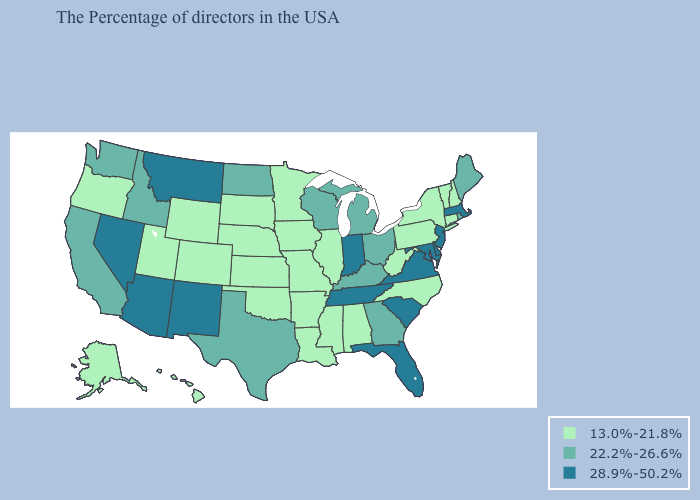Which states have the highest value in the USA?
Concise answer only. Massachusetts, New Jersey, Delaware, Maryland, Virginia, South Carolina, Florida, Indiana, Tennessee, New Mexico, Montana, Arizona, Nevada. Does Michigan have the lowest value in the USA?
Short answer required. No. Name the states that have a value in the range 28.9%-50.2%?
Concise answer only. Massachusetts, New Jersey, Delaware, Maryland, Virginia, South Carolina, Florida, Indiana, Tennessee, New Mexico, Montana, Arizona, Nevada. Among the states that border North Dakota , which have the lowest value?
Quick response, please. Minnesota, South Dakota. Name the states that have a value in the range 13.0%-21.8%?
Give a very brief answer. New Hampshire, Vermont, Connecticut, New York, Pennsylvania, North Carolina, West Virginia, Alabama, Illinois, Mississippi, Louisiana, Missouri, Arkansas, Minnesota, Iowa, Kansas, Nebraska, Oklahoma, South Dakota, Wyoming, Colorado, Utah, Oregon, Alaska, Hawaii. What is the value of Indiana?
Answer briefly. 28.9%-50.2%. How many symbols are there in the legend?
Keep it brief. 3. Does Louisiana have the lowest value in the South?
Give a very brief answer. Yes. What is the value of Vermont?
Give a very brief answer. 13.0%-21.8%. What is the lowest value in the South?
Write a very short answer. 13.0%-21.8%. Among the states that border Oklahoma , does New Mexico have the lowest value?
Concise answer only. No. Among the states that border Minnesota , does South Dakota have the highest value?
Answer briefly. No. Does New Mexico have a higher value than Arizona?
Keep it brief. No. Which states have the lowest value in the USA?
Concise answer only. New Hampshire, Vermont, Connecticut, New York, Pennsylvania, North Carolina, West Virginia, Alabama, Illinois, Mississippi, Louisiana, Missouri, Arkansas, Minnesota, Iowa, Kansas, Nebraska, Oklahoma, South Dakota, Wyoming, Colorado, Utah, Oregon, Alaska, Hawaii. What is the value of Hawaii?
Give a very brief answer. 13.0%-21.8%. 